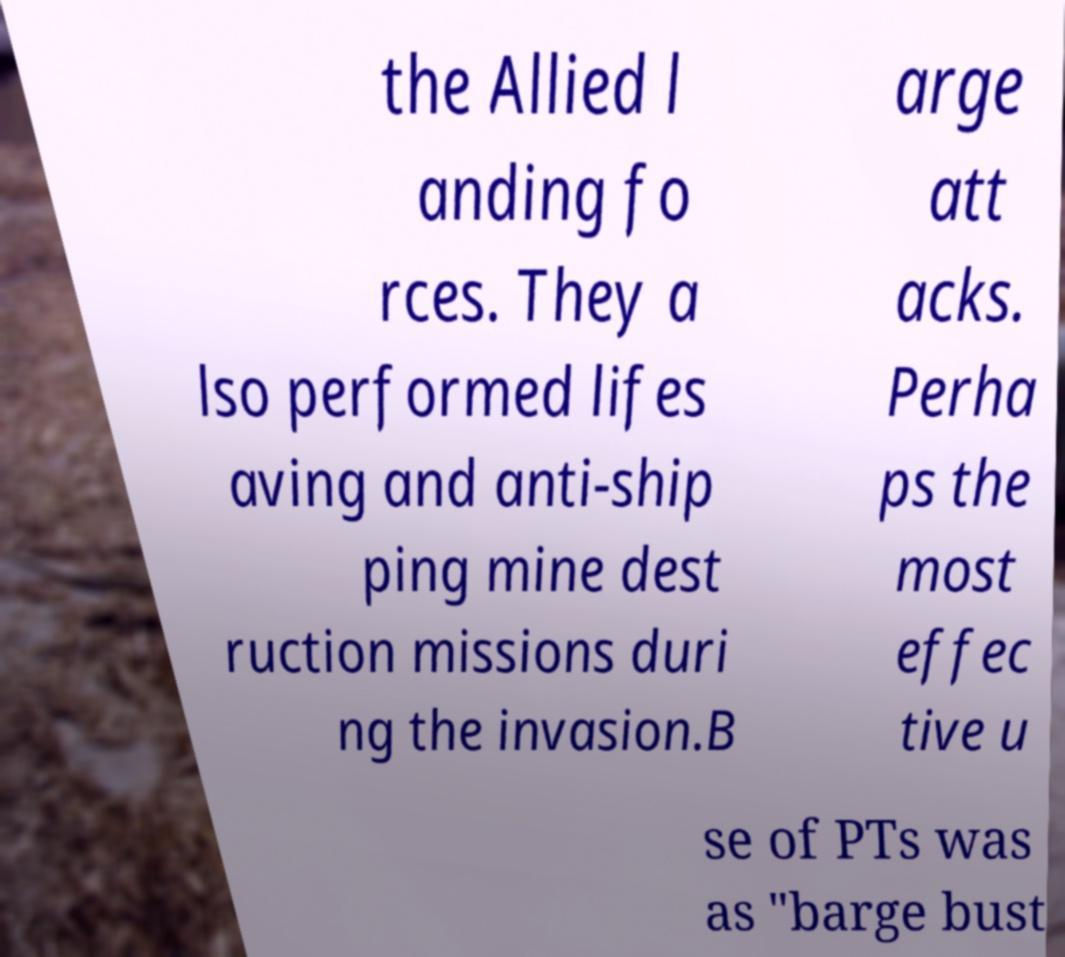Please identify and transcribe the text found in this image. the Allied l anding fo rces. They a lso performed lifes aving and anti-ship ping mine dest ruction missions duri ng the invasion.B arge att acks. Perha ps the most effec tive u se of PTs was as "barge bust 